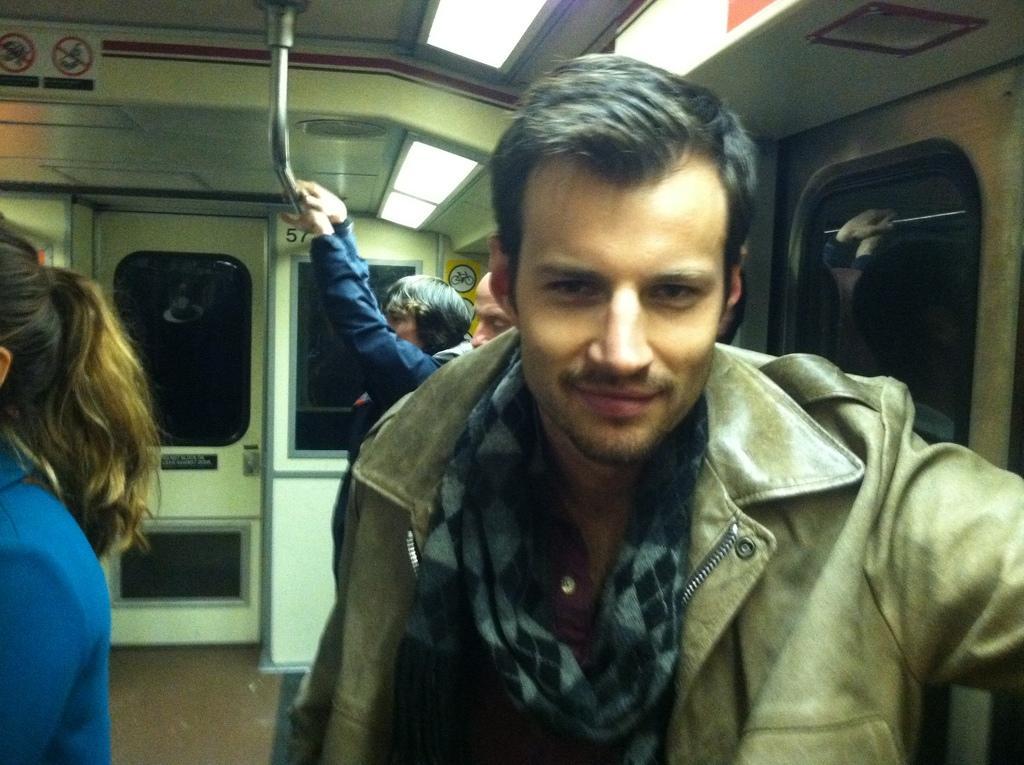In one or two sentences, can you explain what this image depicts? In the image I can see people are standing in a train. In the background I can see a person is holding a metal rod. I can also see windows, lights, a door and some other objects. 